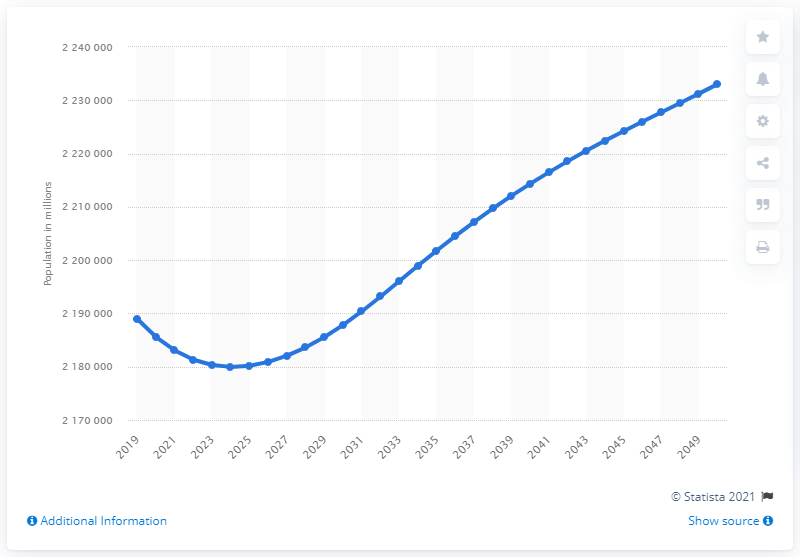Outline some significant characteristics in this image. It is projected that the population of Paris, France will be approximately 2050. 